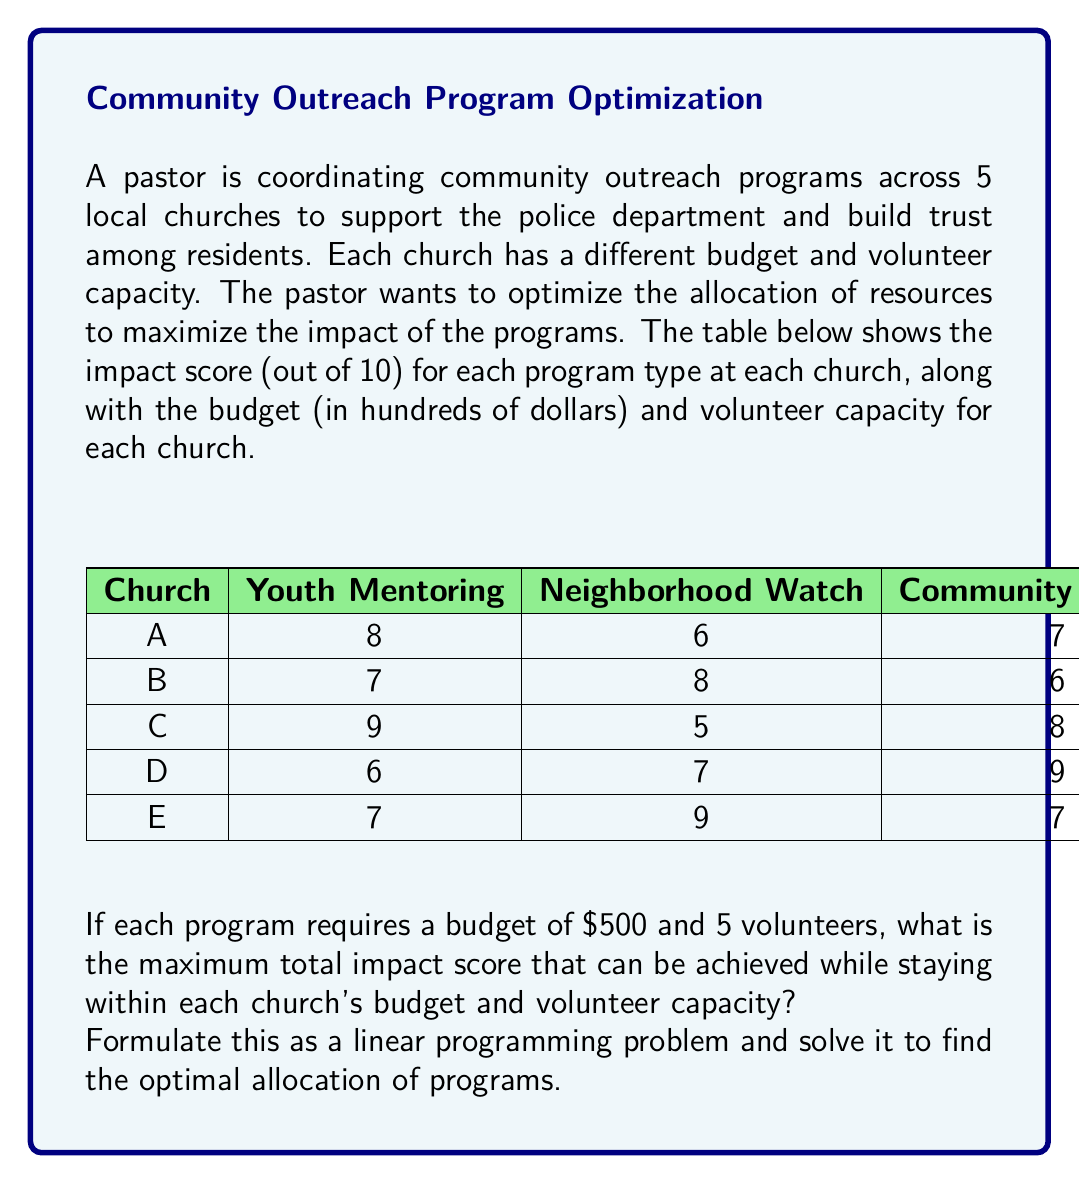Help me with this question. Let's approach this step-by-step:

1) Define variables:
   Let $x_{ij}$ be the number of programs of type $j$ assigned to church $i$
   Where $i = A, B, C, D, E$ and $j = 1 (\text{Youth Mentoring}), 2 (\text{Neighborhood Watch}), 3 (\text{Community Dialogue})$

2) Objective function:
   Maximize total impact:
   $$Z = 8x_{A1} + 6x_{A2} + 7x_{A3} + 7x_{B1} + 8x_{B2} + 6x_{B3} + 9x_{C1} + 5x_{C2} + 8x_{C3} + 6x_{D1} + 7x_{D2} + 9x_{D3} + 7x_{E1} + 9x_{E2} + 7x_{E3}$$

3) Constraints:
   Budget constraints (in hundreds of dollars):
   $$5x_{A1} + 5x_{A2} + 5x_{A3} \leq 15$$
   $$5x_{B1} + 5x_{B2} + 5x_{B3} \leq 12$$
   $$5x_{C1} + 5x_{C2} + 5x_{C3} \leq 18$$
   $$5x_{D1} + 5x_{D2} + 5x_{D3} \leq 10$$
   $$5x_{E1} + 5x_{E2} + 5x_{E3} \leq 14$$

   Volunteer constraints:
   $$5x_{A1} + 5x_{A2} + 5x_{A3} \leq 20$$
   $$5x_{B1} + 5x_{B2} + 5x_{B3} \leq 15$$
   $$5x_{C1} + 5x_{C2} + 5x_{C3} \leq 25$$
   $$5x_{D1} + 5x_{D2} + 5x_{D3} \leq 18$$
   $$5x_{E1} + 5x_{E2} + 5x_{E3} \leq 22$$

   Non-negativity constraints:
   $$x_{ij} \geq 0 \text{ and integer for all } i, j$$

4) Solve using linear programming software or solver:
   The optimal solution is:
   $x_{A1} = 3, x_{B2} = 2, x_{C1} = 3, x_{D3} = 2, x_{E2} = 2$
   All other variables are 0.

5) Calculate the maximum impact score:
   $$Z = 8(3) + 8(2) + 9(3) + 9(2) + 9(2) = 24 + 16 + 27 + 18 + 18 = 103$$

Therefore, the maximum total impact score that can be achieved is 103.
Answer: 103 